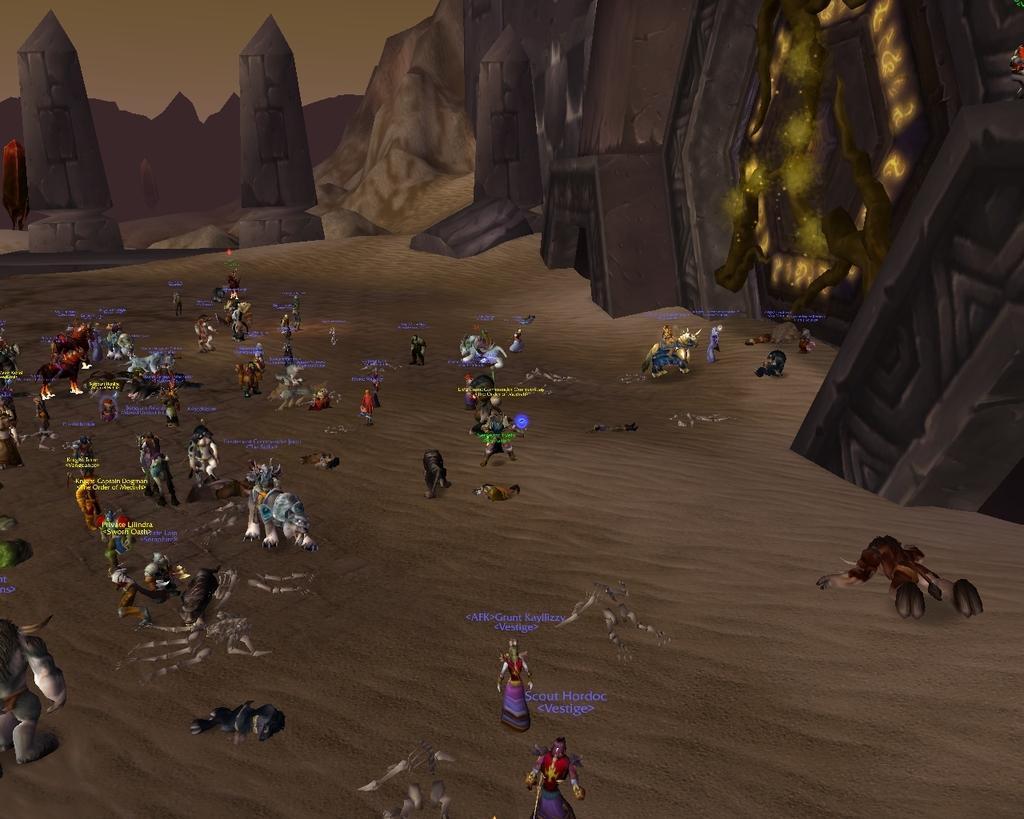In one or two sentences, can you explain what this image depicts? This is an animated image we can see few persons on the sand, texts and objects. In the background we can see mountains, towers, wall, sky and objects. 